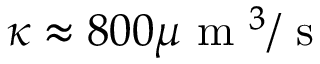<formula> <loc_0><loc_0><loc_500><loc_500>\kappa \approx 8 0 0 \mu m ^ { 3 } / s</formula> 